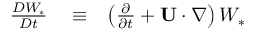Convert formula to latex. <formula><loc_0><loc_0><loc_500><loc_500>\begin{array} { r l r } { \frac { D W _ { \ast } } { D t } } & \equiv } & { \left ( { \frac { \partial } { \partial t } + { U } \cdot \nabla } \right ) W _ { \ast } } \end{array}</formula> 